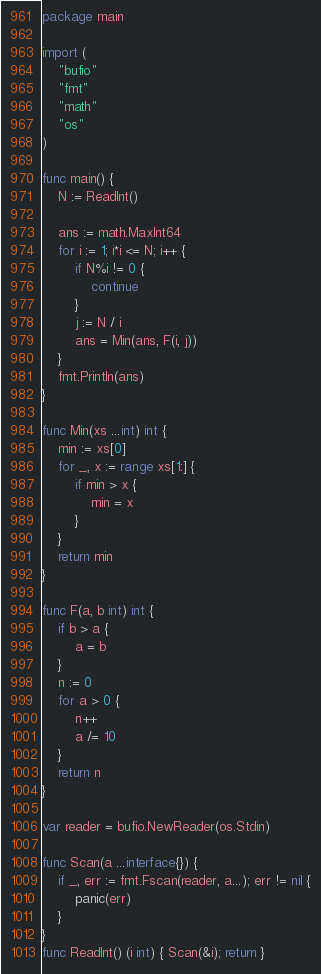<code> <loc_0><loc_0><loc_500><loc_500><_Go_>package main

import (
	"bufio"
	"fmt"
	"math"
	"os"
)

func main() {
	N := ReadInt()

	ans := math.MaxInt64
	for i := 1; i*i <= N; i++ {
		if N%i != 0 {
			continue
		}
		j := N / i
		ans = Min(ans, F(i, j))
	}
	fmt.Println(ans)
}

func Min(xs ...int) int {
	min := xs[0]
	for _, x := range xs[1:] {
		if min > x {
			min = x
		}
	}
	return min
}

func F(a, b int) int {
	if b > a {
		a = b
	}
	n := 0
	for a > 0 {
		n++
		a /= 10
	}
	return n
}

var reader = bufio.NewReader(os.Stdin)

func Scan(a ...interface{}) {
	if _, err := fmt.Fscan(reader, a...); err != nil {
		panic(err)
	}
}
func ReadInt() (i int) { Scan(&i); return }
</code> 